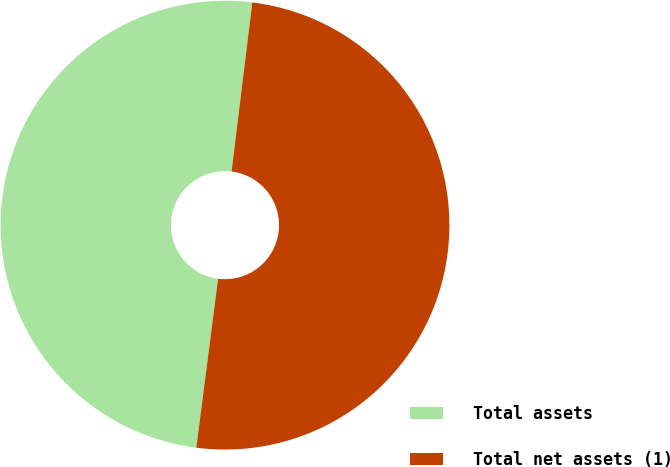Convert chart. <chart><loc_0><loc_0><loc_500><loc_500><pie_chart><fcel>Total assets<fcel>Total net assets (1)<nl><fcel>49.9%<fcel>50.1%<nl></chart> 